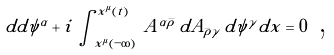<formula> <loc_0><loc_0><loc_500><loc_500>d d { \psi } ^ { \alpha } + i \, \int _ { x ^ { \mu } ( - \infty ) } ^ { x ^ { \mu } ( t ) } \, A ^ { \alpha \bar { \rho } } \, d A _ { \bar { \rho } \gamma } \, d { \psi } ^ { \gamma } d x = 0 \text { ,}</formula> 